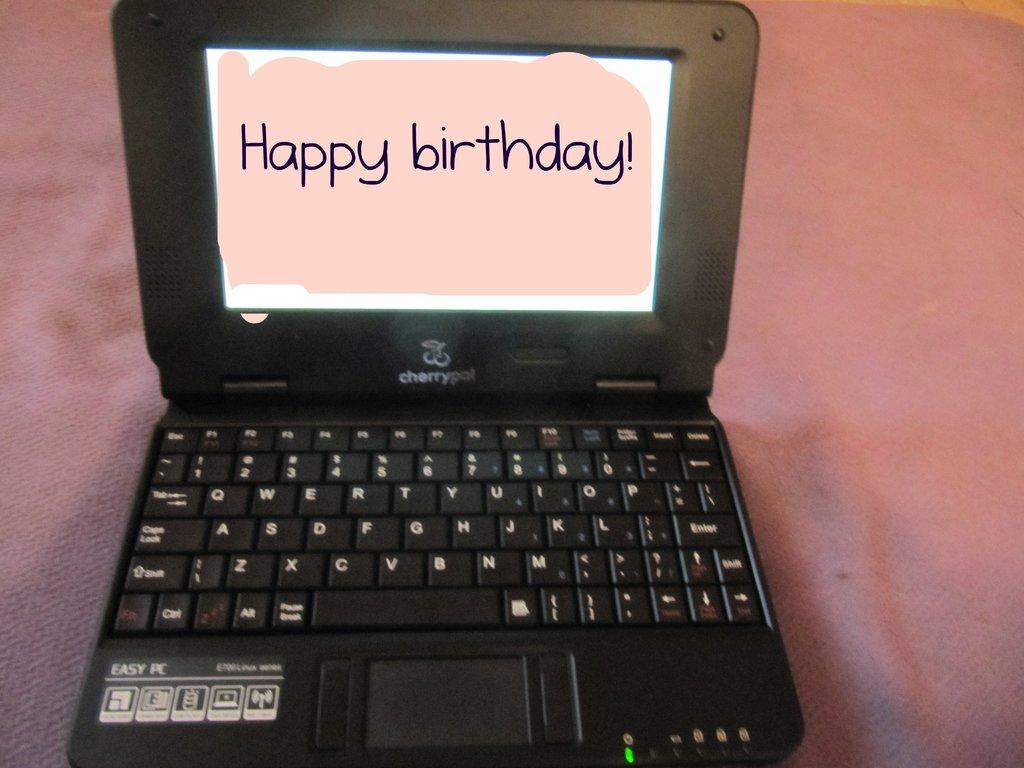<image>
Write a terse but informative summary of the picture. An open laptop has happy birthday on the screen. 